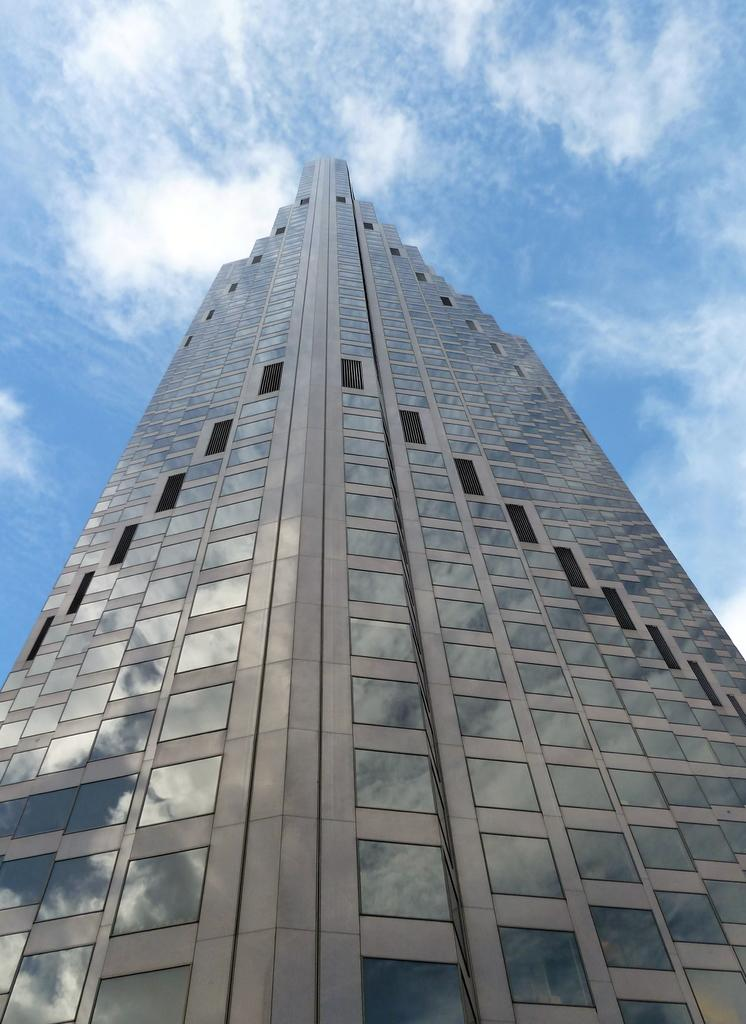What type of structure is visible in the image? There is a building in the image. What is the condition of the sky in the image? The sky is cloudy in the image. How does the building aid in the digestion process in the image? The building does not aid in the digestion process; it is a structure and not related to digestion. 